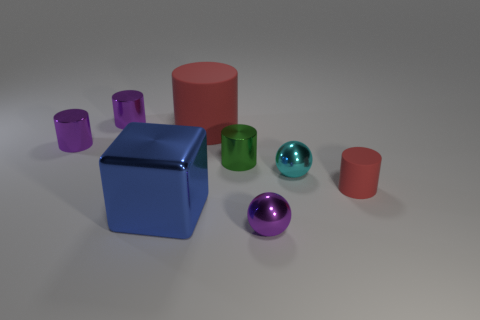Subtract 1 cylinders. How many cylinders are left? 4 Subtract all big cylinders. How many cylinders are left? 4 Subtract all green cylinders. How many cylinders are left? 4 Subtract all yellow cylinders. Subtract all brown blocks. How many cylinders are left? 5 Add 1 big things. How many objects exist? 9 Subtract all cubes. How many objects are left? 7 Add 6 big gray rubber cubes. How many big gray rubber cubes exist? 6 Subtract 0 yellow balls. How many objects are left? 8 Subtract all small red things. Subtract all small cylinders. How many objects are left? 3 Add 4 purple metal spheres. How many purple metal spheres are left? 5 